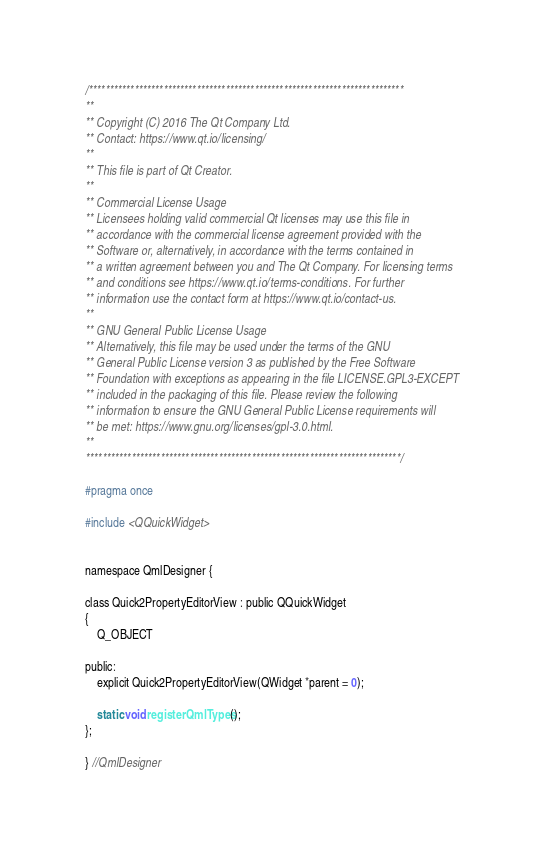<code> <loc_0><loc_0><loc_500><loc_500><_C_>/****************************************************************************
**
** Copyright (C) 2016 The Qt Company Ltd.
** Contact: https://www.qt.io/licensing/
**
** This file is part of Qt Creator.
**
** Commercial License Usage
** Licensees holding valid commercial Qt licenses may use this file in
** accordance with the commercial license agreement provided with the
** Software or, alternatively, in accordance with the terms contained in
** a written agreement between you and The Qt Company. For licensing terms
** and conditions see https://www.qt.io/terms-conditions. For further
** information use the contact form at https://www.qt.io/contact-us.
**
** GNU General Public License Usage
** Alternatively, this file may be used under the terms of the GNU
** General Public License version 3 as published by the Free Software
** Foundation with exceptions as appearing in the file LICENSE.GPL3-EXCEPT
** included in the packaging of this file. Please review the following
** information to ensure the GNU General Public License requirements will
** be met: https://www.gnu.org/licenses/gpl-3.0.html.
**
****************************************************************************/

#pragma once

#include <QQuickWidget>


namespace QmlDesigner {

class Quick2PropertyEditorView : public QQuickWidget
{
    Q_OBJECT

public:
    explicit Quick2PropertyEditorView(QWidget *parent = 0);

    static void registerQmlTypes();
};

} //QmlDesigner
</code> 